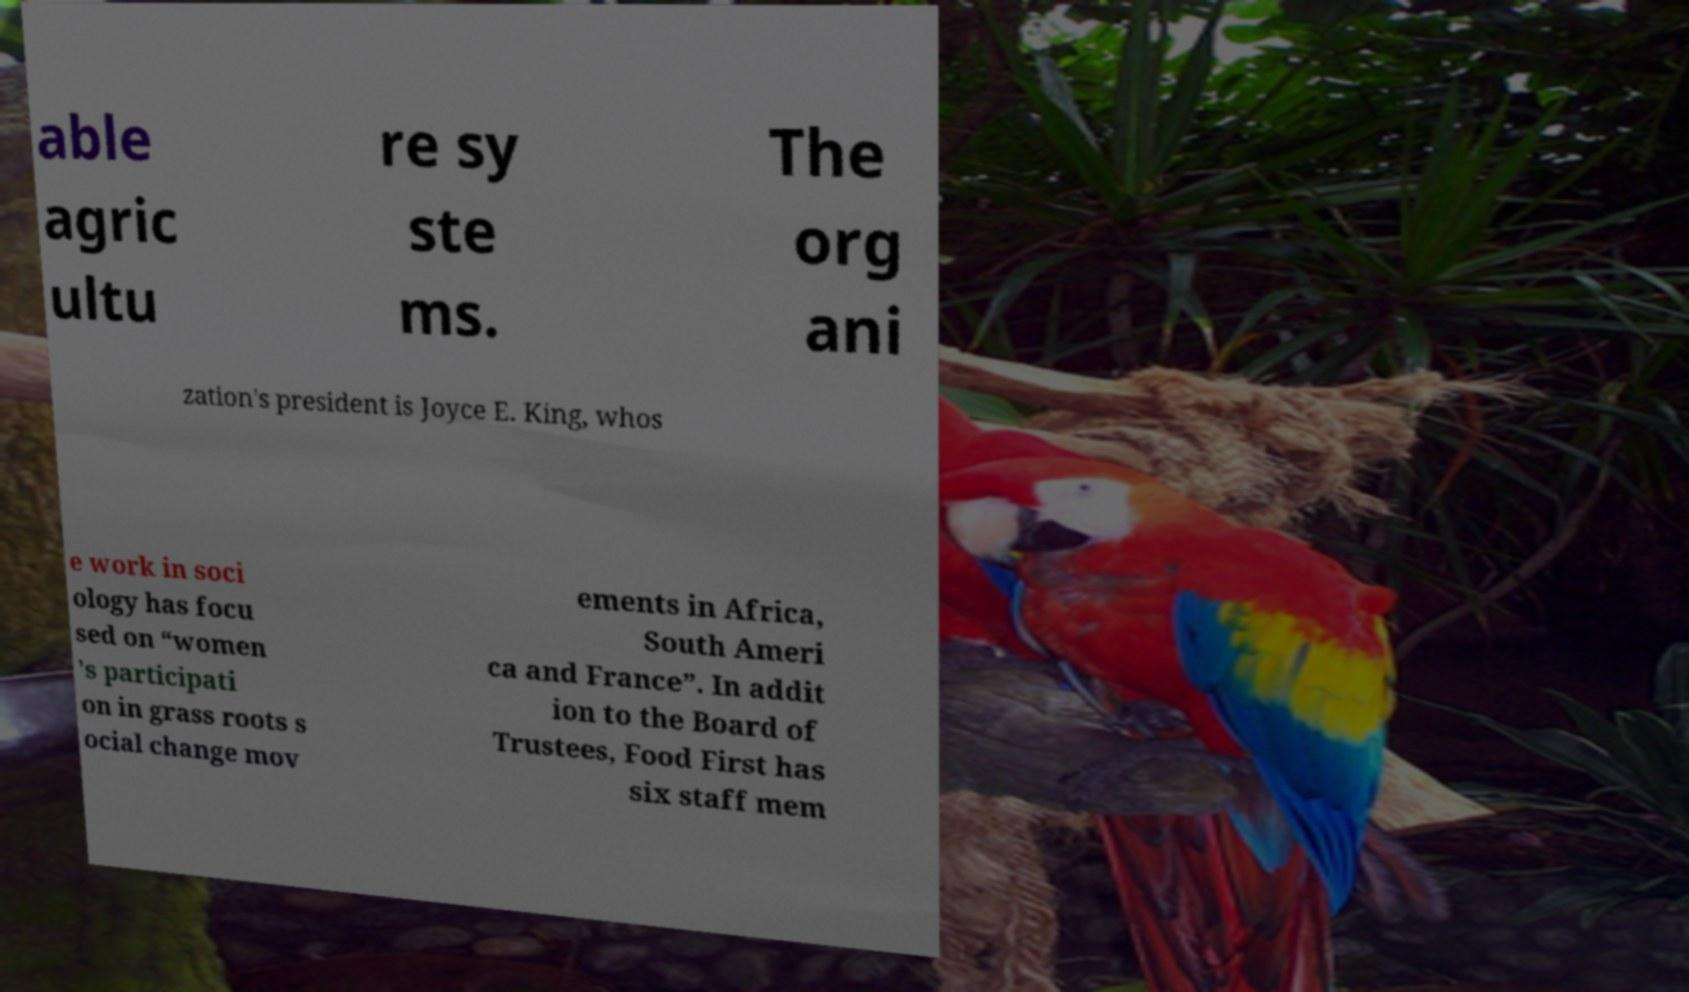There's text embedded in this image that I need extracted. Can you transcribe it verbatim? able agric ultu re sy ste ms. The org ani zation's president is Joyce E. King, whos e work in soci ology has focu sed on “women 's participati on in grass roots s ocial change mov ements in Africa, South Ameri ca and France”. In addit ion to the Board of Trustees, Food First has six staff mem 